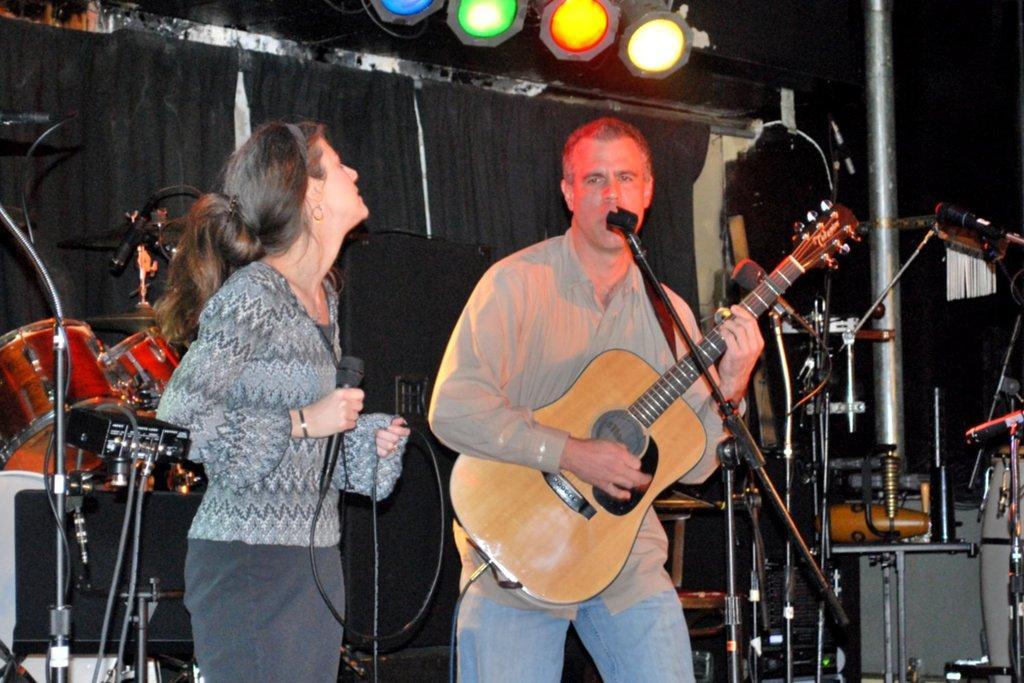In one or two sentences, can you explain what this image depicts? In this image I can see a man and a woman are standing. I can see he is holding a guitar and she is holding a mic. In the background I can see a drum set, few mics and few lights. 